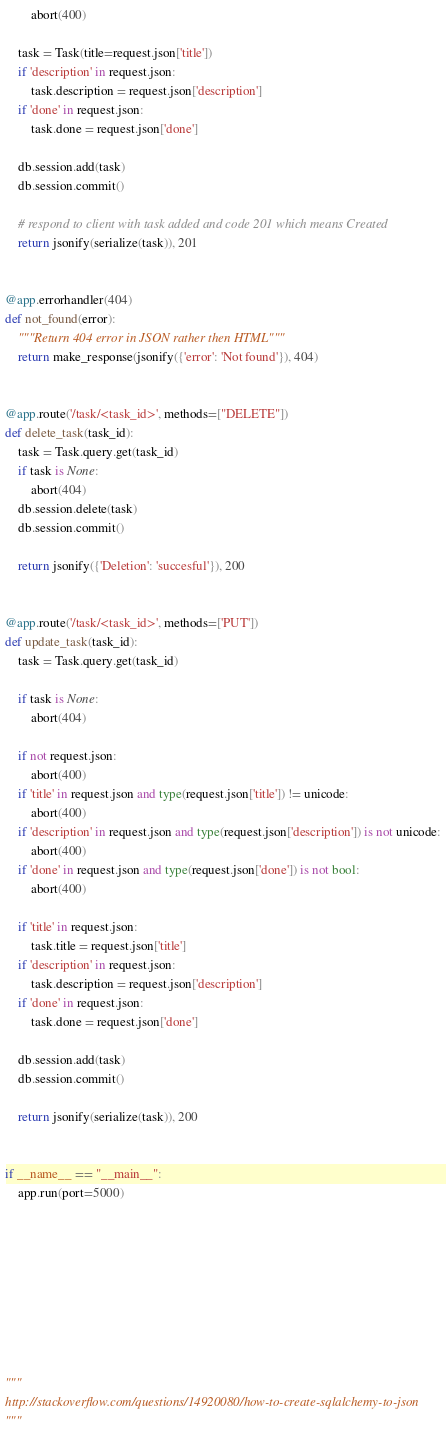<code> <loc_0><loc_0><loc_500><loc_500><_Python_>		abort(400)

	task = Task(title=request.json['title'])
	if 'description' in request.json:
		task.description = request.json['description']
	if 'done' in request.json:
		task.done = request.json['done']

	db.session.add(task)
	db.session.commit()

	# respond to client with task added and code 201 which means Created
	return jsonify(serialize(task)), 201


@app.errorhandler(404)
def not_found(error):
	"""Return 404 error in JSON rather then HTML"""
	return make_response(jsonify({'error': 'Not found'}), 404)


@app.route('/task/<task_id>', methods=["DELETE"])
def delete_task(task_id):
    task = Task.query.get(task_id)
    if task is None:
        abort(404)
    db.session.delete(task)
    db.session.commit()

    return jsonify({'Deletion': 'succesful'}), 200


@app.route('/task/<task_id>', methods=['PUT'])
def update_task(task_id):
	task = Task.query.get(task_id)

	if task is None:
		abort(404)

	if not request.json:
		abort(400)
	if 'title' in request.json and type(request.json['title']) != unicode:
		abort(400)
	if 'description' in request.json and type(request.json['description']) is not unicode:
		abort(400)
	if 'done' in request.json and type(request.json['done']) is not bool:
		abort(400)

	if 'title' in request.json:
		task.title = request.json['title']
	if 'description' in request.json:
		task.description = request.json['description']
	if 'done' in request.json:
		task.done = request.json['done']

	db.session.add(task)
	db.session.commit()

	return jsonify(serialize(task)), 200


if __name__ == "__main__":
	app.run(port=5000)









"""
http://stackoverflow.com/questions/14920080/how-to-create-sqlalchemy-to-json
"""</code> 